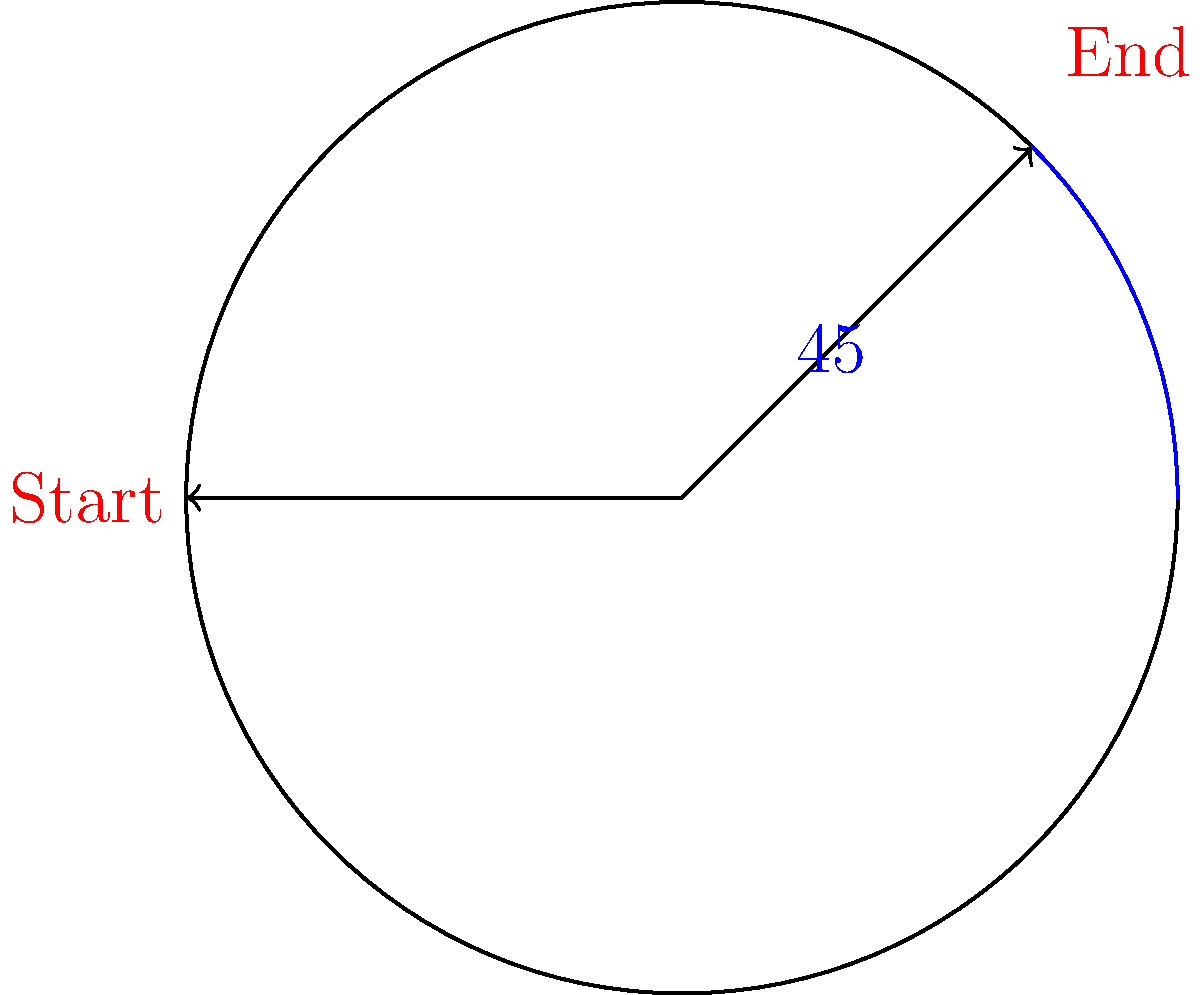You're listening to your favorite grunge album on vinyl, trying to find some peace in the music. The turntable rotates at 33 1/3 RPM (revolutions per minute). If the needle has been playing for 2 minutes and 15 seconds, what is the total angle of rotation in degrees? Let's break this down step-by-step:

1) First, we need to convert the time to minutes:
   2 minutes and 15 seconds = 2.25 minutes

2) We know the turntable rotates at 33 1/3 RPM, which means:
   33 1/3 rotations in 1 minute

3) To find the number of rotations in 2.25 minutes:
   $33\frac{1}{3} \times 2.25 = 75$ rotations

4) Now, we need to convert rotations to degrees:
   1 rotation = 360°

5) So, 75 rotations would be:
   $75 \times 360° = 27,000°$

The total angle of rotation is 27,000°.
Answer: 27,000° 